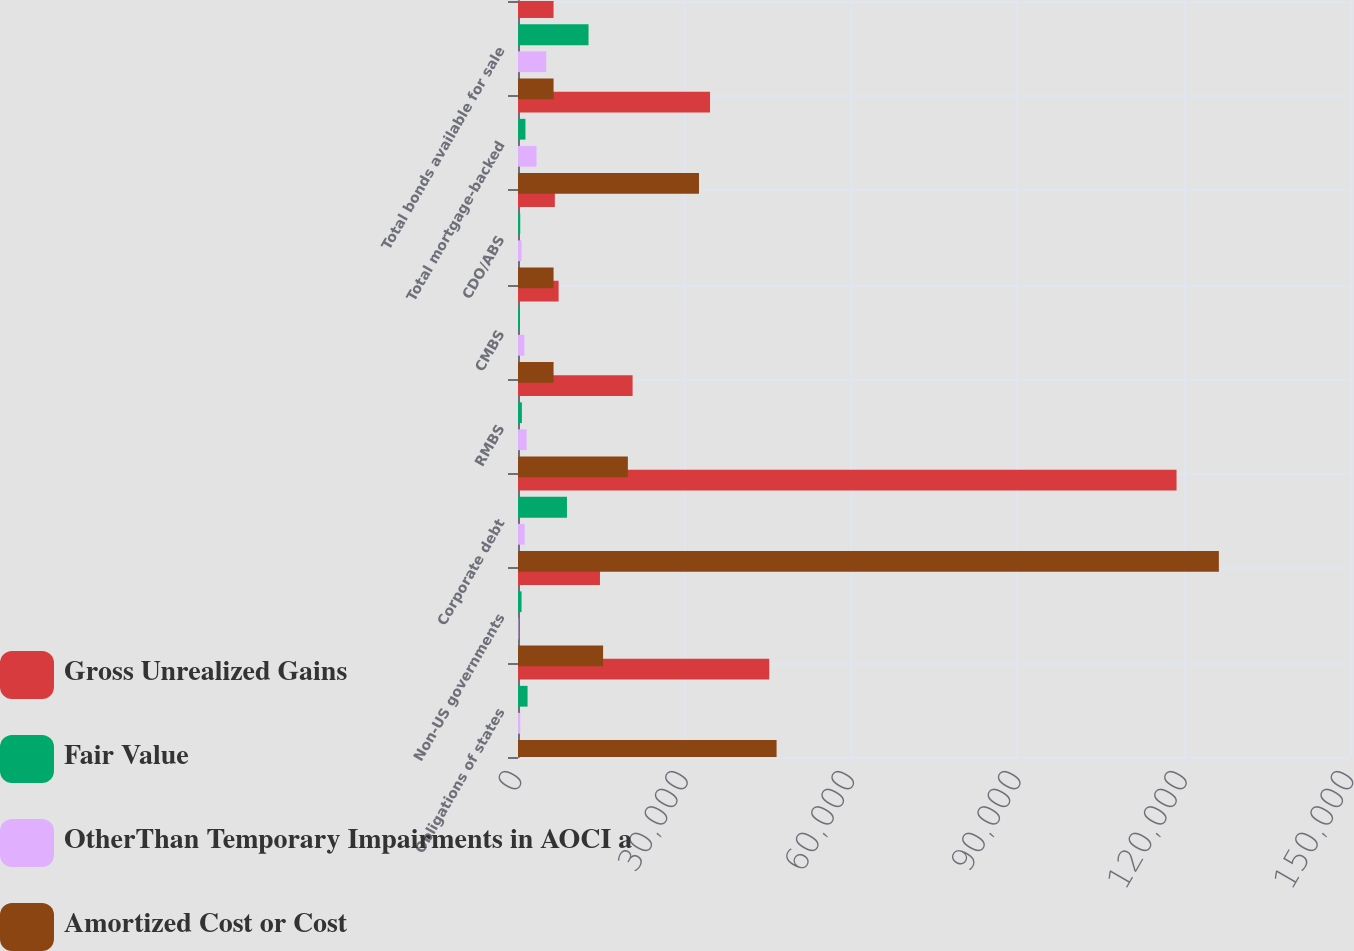<chart> <loc_0><loc_0><loc_500><loc_500><stacked_bar_chart><ecel><fcel>Obligations of states<fcel>Non-US governments<fcel>Corporate debt<fcel>RMBS<fcel>CMBS<fcel>CDO/ABS<fcel>Total mortgage-backed<fcel>Total bonds available for sale<nl><fcel>Gross Unrealized Gains<fcel>45297<fcel>14780<fcel>118729<fcel>20661<fcel>7320<fcel>6643<fcel>34624<fcel>6411<nl><fcel>Fair Value<fcel>1725<fcel>639<fcel>8827<fcel>700<fcel>240<fcel>402<fcel>1342<fcel>12717<nl><fcel>OtherThan Temporary Impairments in AOCI a<fcel>402<fcel>75<fcel>1198<fcel>1553<fcel>1149<fcel>634<fcel>3336<fcel>5084<nl><fcel>Amortized Cost or Cost<fcel>46620<fcel>15344<fcel>126358<fcel>19808<fcel>6411<fcel>6411<fcel>32630<fcel>6411<nl></chart> 